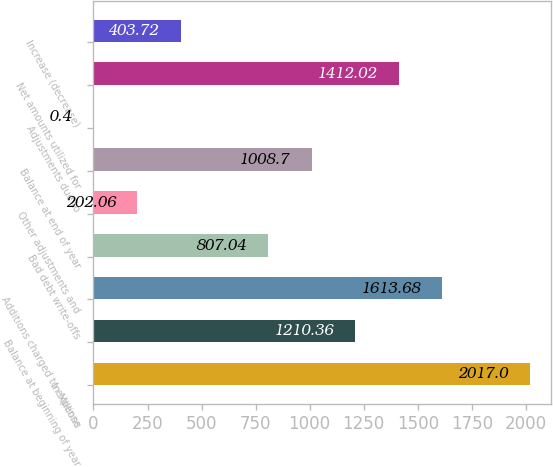Convert chart to OTSL. <chart><loc_0><loc_0><loc_500><loc_500><bar_chart><fcel>In Millions<fcel>Balance at beginning of year<fcel>Additions charged to expense<fcel>Bad debt write-offs<fcel>Other adjustments and<fcel>Balance at end of year<fcel>Adjustments due to<fcel>Net amounts utilized for<fcel>Increase (decrease)<nl><fcel>2017<fcel>1210.36<fcel>1613.68<fcel>807.04<fcel>202.06<fcel>1008.7<fcel>0.4<fcel>1412.02<fcel>403.72<nl></chart> 